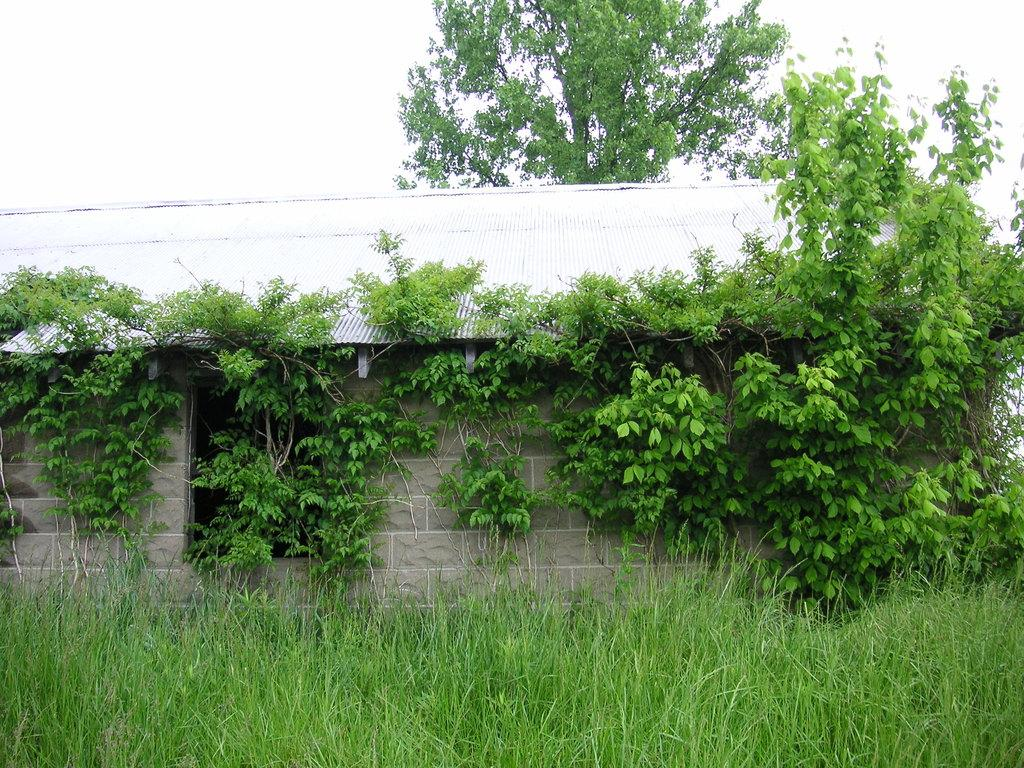What type of vegetation can be seen in the image? There are grass plants in the image. What type of structure is present in the image? There is a house in the image. Are there any plants near the house? Yes, there are plants near the house. What can be seen in the background of the image? There is a tree and the sky visible in the background of the image. What type of pen is visible in the image? There is no pen present in the image. Is the house located in space in the image? No, the house is not located in space; it is on the ground with grass plants, trees, and the sky visible in the background. 